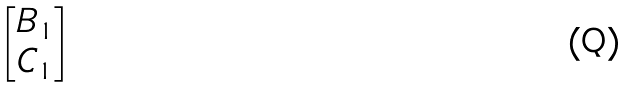<formula> <loc_0><loc_0><loc_500><loc_500>\begin{bmatrix} B _ { 1 } \\ C _ { 1 } \end{bmatrix}</formula> 